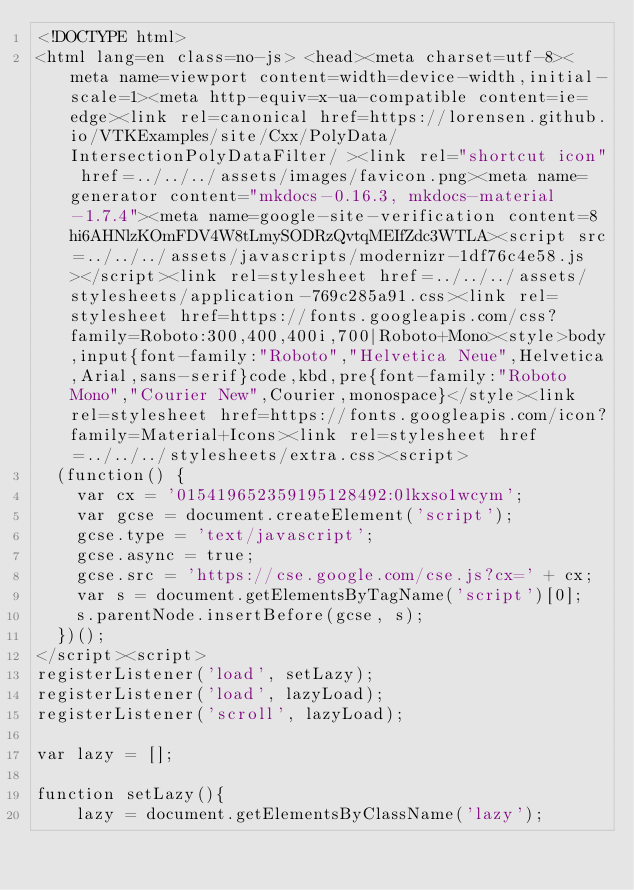<code> <loc_0><loc_0><loc_500><loc_500><_HTML_><!DOCTYPE html>
<html lang=en class=no-js> <head><meta charset=utf-8><meta name=viewport content=width=device-width,initial-scale=1><meta http-equiv=x-ua-compatible content=ie=edge><link rel=canonical href=https://lorensen.github.io/VTKExamples/site/Cxx/PolyData/IntersectionPolyDataFilter/ ><link rel="shortcut icon" href=../../../assets/images/favicon.png><meta name=generator content="mkdocs-0.16.3, mkdocs-material-1.7.4"><meta name=google-site-verification content=8hi6AHNlzKOmFDV4W8tLmySODRzQvtqMEIfZdc3WTLA><script src=../../../assets/javascripts/modernizr-1df76c4e58.js></script><link rel=stylesheet href=../../../assets/stylesheets/application-769c285a91.css><link rel=stylesheet href=https://fonts.googleapis.com/css?family=Roboto:300,400,400i,700|Roboto+Mono><style>body,input{font-family:"Roboto","Helvetica Neue",Helvetica,Arial,sans-serif}code,kbd,pre{font-family:"Roboto Mono","Courier New",Courier,monospace}</style><link rel=stylesheet href=https://fonts.googleapis.com/icon?family=Material+Icons><link rel=stylesheet href=../../../stylesheets/extra.css><script>
  (function() {
    var cx = '015419652359195128492:0lkxso1wcym';
    var gcse = document.createElement('script');
    gcse.type = 'text/javascript';
    gcse.async = true;
    gcse.src = 'https://cse.google.com/cse.js?cx=' + cx;
    var s = document.getElementsByTagName('script')[0];
    s.parentNode.insertBefore(gcse, s);
  })();
</script><script>
registerListener('load', setLazy);
registerListener('load', lazyLoad);
registerListener('scroll', lazyLoad);

var lazy = [];

function setLazy(){
    lazy = document.getElementsByClassName('lazy');</code> 